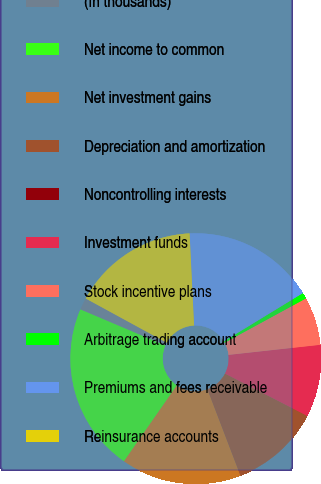Convert chart to OTSL. <chart><loc_0><loc_0><loc_500><loc_500><pie_chart><fcel>(In thousands)<fcel>Net income to common<fcel>Net investment gains<fcel>Depreciation and amortization<fcel>Noncontrolling interests<fcel>Investment funds<fcel>Stock incentive plans<fcel>Arbitrage trading account<fcel>Premiums and fees receivable<fcel>Reinsurance accounts<nl><fcel>1.55%<fcel>21.71%<fcel>15.5%<fcel>11.63%<fcel>0.0%<fcel>9.3%<fcel>6.2%<fcel>0.78%<fcel>17.05%<fcel>16.28%<nl></chart> 